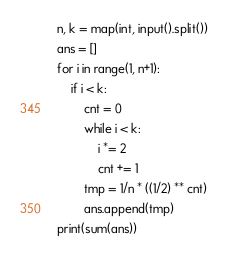<code> <loc_0><loc_0><loc_500><loc_500><_Python_>n, k = map(int, input().split())
ans = []
for i in range(1, n+1):
    if i < k:
        cnt = 0
        while i < k:
            i *= 2
            cnt += 1
        tmp = 1/n * ((1/2) ** cnt)
        ans.append(tmp)
print(sum(ans))</code> 